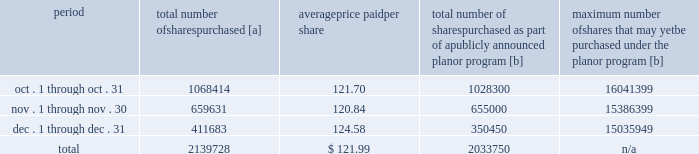Five-year performance comparison 2013 the following graph provides an indicator of cumulative total shareholder returns for the corporation as compared to the peer group index ( described above ) , the dj trans , and the s&p 500 .
The graph assumes that $ 100 was invested in the common stock of union pacific corporation and each index on december 31 , 2007 and that all dividends were reinvested .
Purchases of equity securities 2013 during 2012 , we repurchased 13804709 shares of our common stock at an average price of $ 115.33 .
The table presents common stock repurchases during each month for the fourth quarter of 2012 : period total number of shares purchased [a] average price paid per share total number of shares purchased as part of a publicly announced plan or program [b] maximum number of shares that may yet be purchased under the plan or program [b] .
[a] total number of shares purchased during the quarter includes approximately 105978 shares delivered or attested to upc by employees to pay stock option exercise prices , satisfy excess tax withholding obligations for stock option exercises or vesting of retention units , and pay withholding obligations for vesting of retention shares .
[b] on april 1 , 2011 , our board of directors authorized the repurchase of up to 40 million shares of our common stock by march 31 , 2014 .
These repurchases may be made on the open market or through other transactions .
Our management has sole discretion with respect to determining the timing and amount of these transactions. .
What was the cost of total share repurchases during 2012? 
Computations: (13804709 * 115.33)
Answer: 1592097088.97. Five-year performance comparison 2013 the following graph provides an indicator of cumulative total shareholder returns for the corporation as compared to the peer group index ( described above ) , the dj trans , and the s&p 500 .
The graph assumes that $ 100 was invested in the common stock of union pacific corporation and each index on december 31 , 2007 and that all dividends were reinvested .
Purchases of equity securities 2013 during 2012 , we repurchased 13804709 shares of our common stock at an average price of $ 115.33 .
The table presents common stock repurchases during each month for the fourth quarter of 2012 : period total number of shares purchased [a] average price paid per share total number of shares purchased as part of a publicly announced plan or program [b] maximum number of shares that may yet be purchased under the plan or program [b] .
[a] total number of shares purchased during the quarter includes approximately 105978 shares delivered or attested to upc by employees to pay stock option exercise prices , satisfy excess tax withholding obligations for stock option exercises or vesting of retention units , and pay withholding obligations for vesting of retention shares .
[b] on april 1 , 2011 , our board of directors authorized the repurchase of up to 40 million shares of our common stock by march 31 , 2014 .
These repurchases may be made on the open market or through other transactions .
Our management has sole discretion with respect to determining the timing and amount of these transactions. .
What percentage of the total number of shares purchased were purchased in october? 
Computations: (1068414 / 2139728)
Answer: 0.49932. 